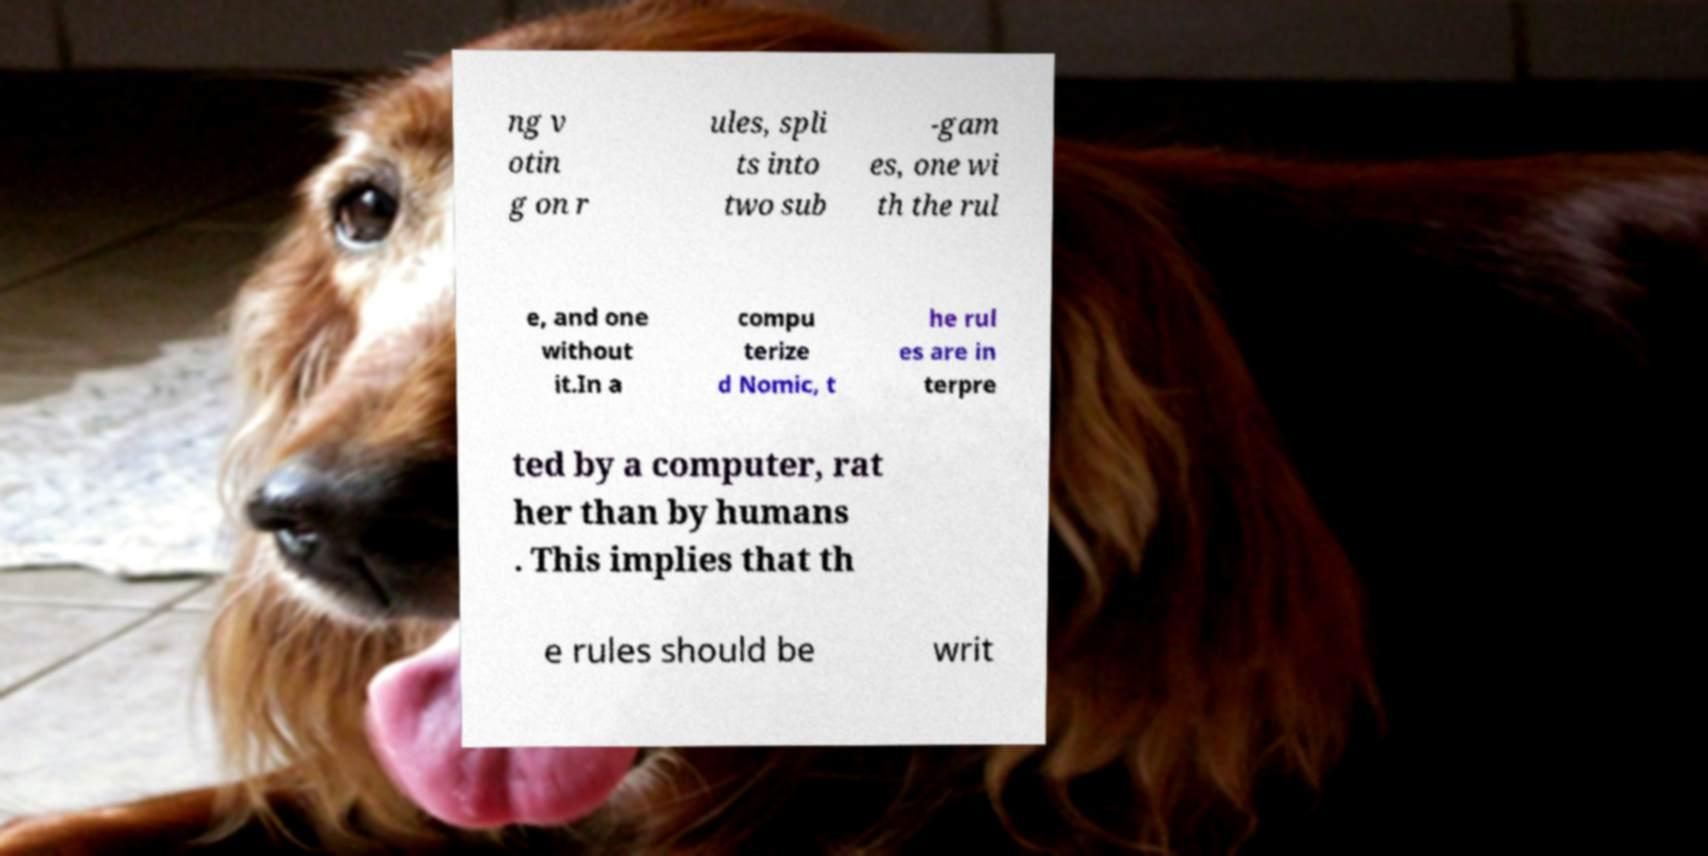Please identify and transcribe the text found in this image. ng v otin g on r ules, spli ts into two sub -gam es, one wi th the rul e, and one without it.In a compu terize d Nomic, t he rul es are in terpre ted by a computer, rat her than by humans . This implies that th e rules should be writ 